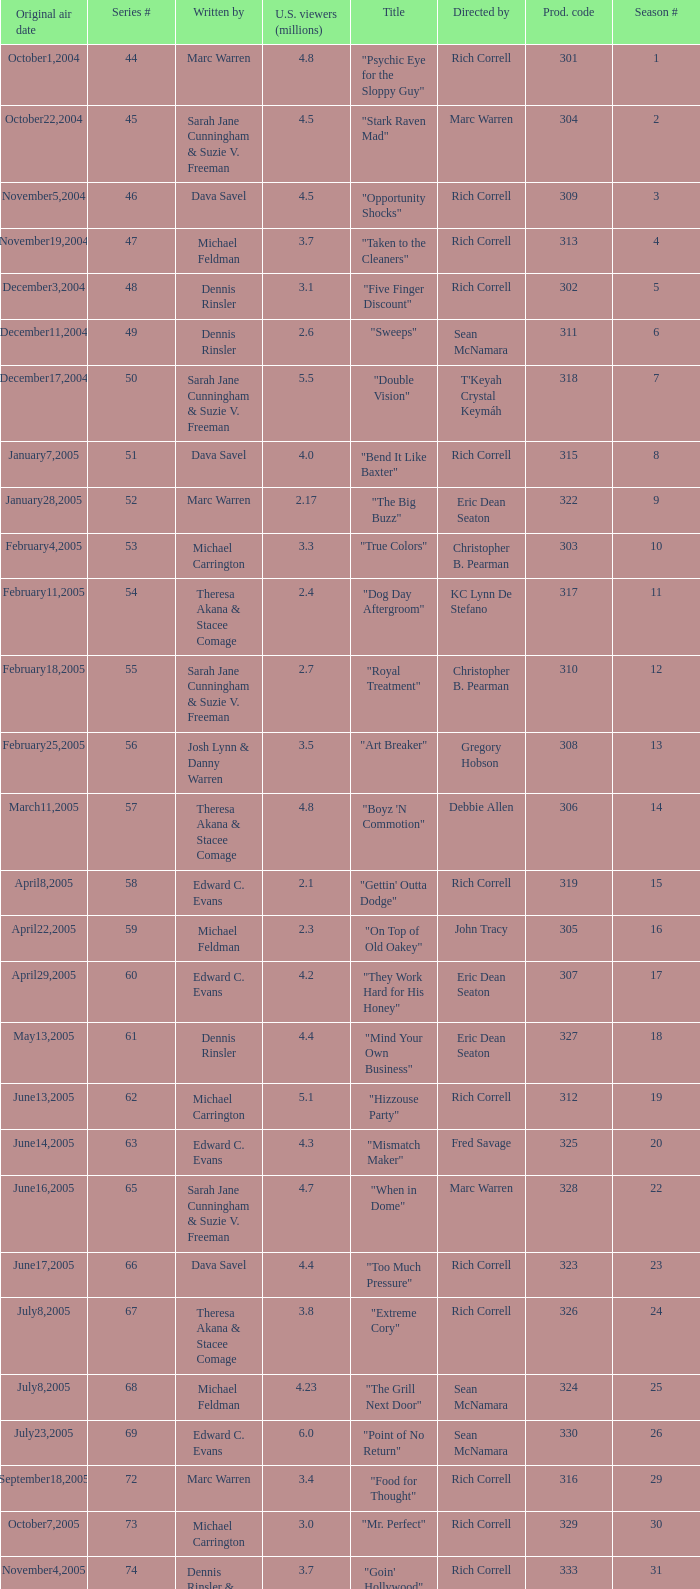What number episode in the season had a production code of 334? 32.0. 